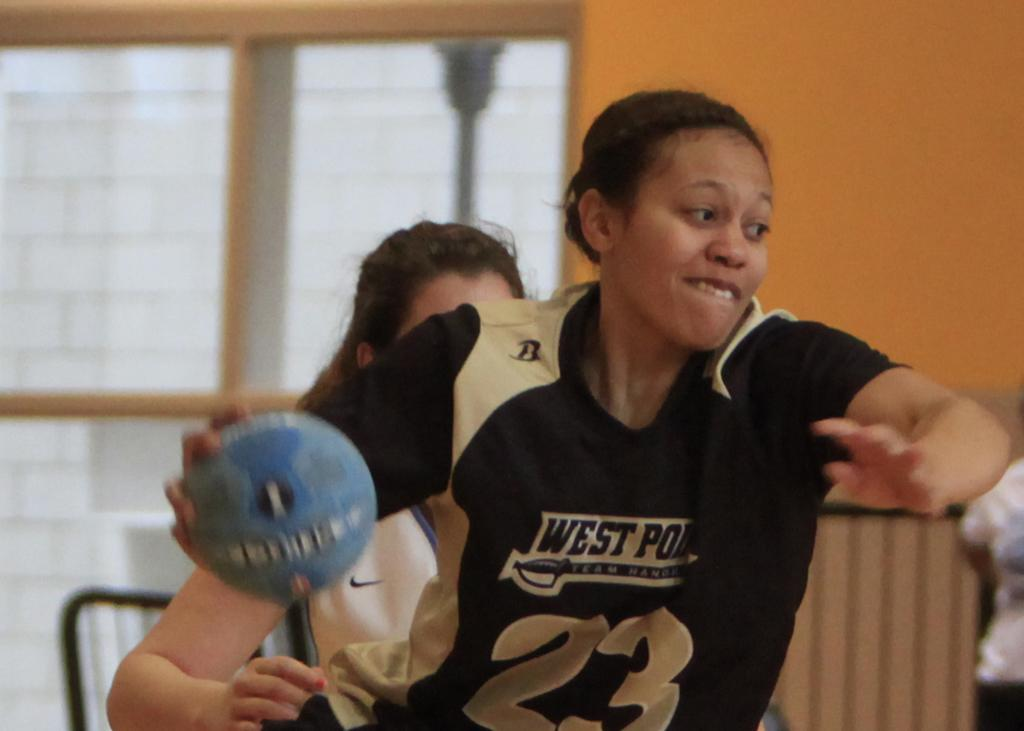What is the woman holding in the image? The woman is holding a ball. Can you describe the people visible in the image? There are people visible in the image, but their specific actions or characteristics are not mentioned in the provided facts. What is located near the window in the image? The grill and pole are located near the window in the image. What type of structure is present in the image? There is a wall in the image. What type of spot can be seen on the woman's shirt in the image? There is no mention of a spot on the woman's shirt in the provided facts, so it cannot be determined from the image. 